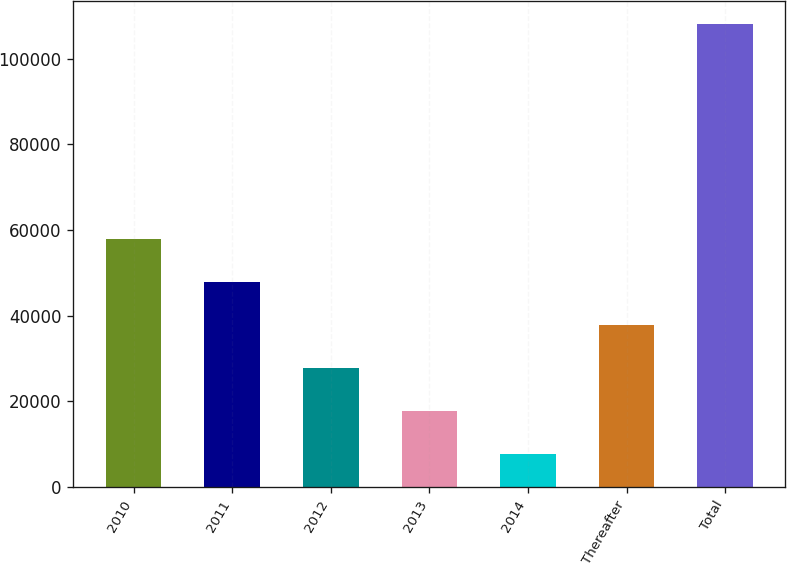<chart> <loc_0><loc_0><loc_500><loc_500><bar_chart><fcel>2010<fcel>2011<fcel>2012<fcel>2013<fcel>2014<fcel>Thereafter<fcel>Total<nl><fcel>57897<fcel>47866<fcel>27804<fcel>17773<fcel>7742<fcel>37835<fcel>108052<nl></chart> 